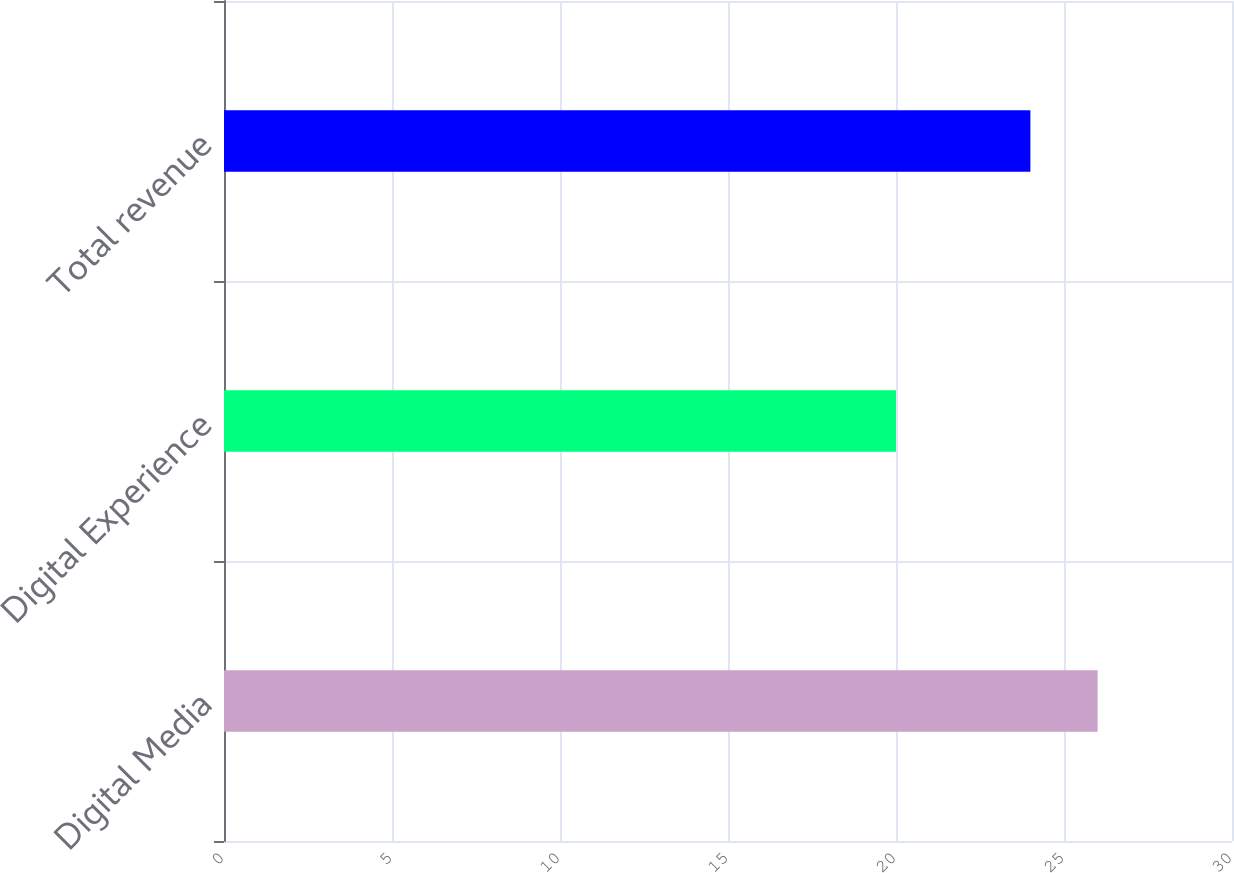Convert chart. <chart><loc_0><loc_0><loc_500><loc_500><bar_chart><fcel>Digital Media<fcel>Digital Experience<fcel>Total revenue<nl><fcel>26<fcel>20<fcel>24<nl></chart> 